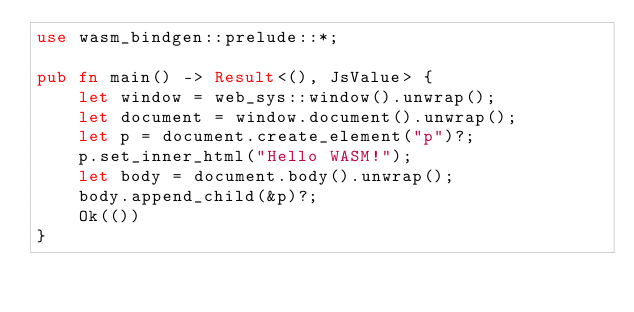<code> <loc_0><loc_0><loc_500><loc_500><_Rust_>use wasm_bindgen::prelude::*;

pub fn main() -> Result<(), JsValue> {
    let window = web_sys::window().unwrap();
    let document = window.document().unwrap();
    let p = document.create_element("p")?;
    p.set_inner_html("Hello WASM!");
    let body = document.body().unwrap();
    body.append_child(&p)?;
    Ok(())
}
</code> 